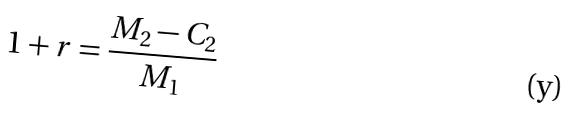<formula> <loc_0><loc_0><loc_500><loc_500>1 + r = \frac { M _ { 2 } - C _ { 2 } } { M _ { 1 } }</formula> 